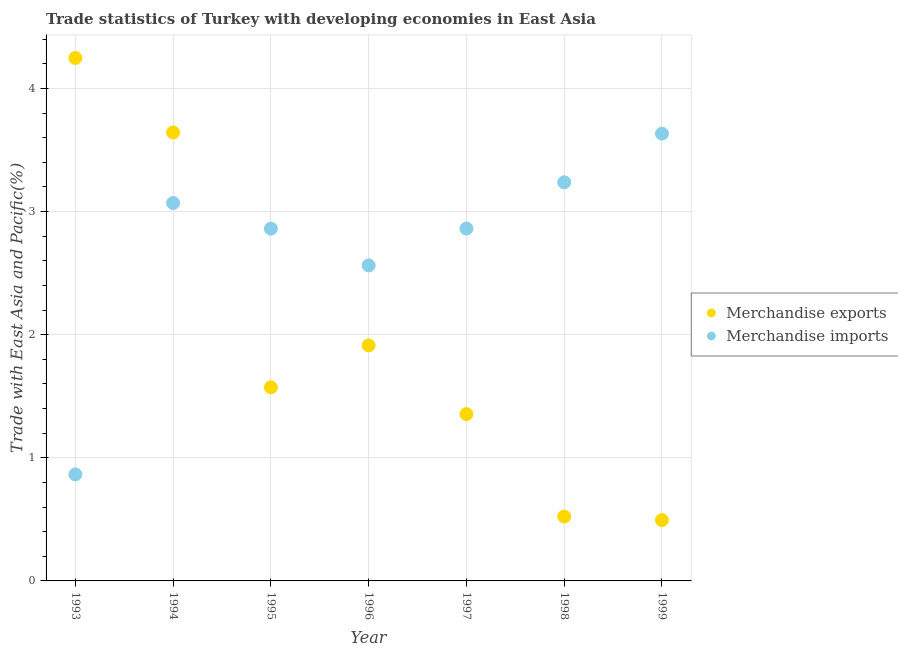How many different coloured dotlines are there?
Give a very brief answer. 2. What is the merchandise exports in 1999?
Your answer should be compact. 0.49. Across all years, what is the maximum merchandise imports?
Make the answer very short. 3.63. Across all years, what is the minimum merchandise exports?
Make the answer very short. 0.49. What is the total merchandise imports in the graph?
Give a very brief answer. 19.09. What is the difference between the merchandise imports in 1998 and that in 1999?
Ensure brevity in your answer.  -0.4. What is the difference between the merchandise exports in 1993 and the merchandise imports in 1996?
Offer a terse response. 1.68. What is the average merchandise exports per year?
Offer a terse response. 1.96. In the year 1996, what is the difference between the merchandise imports and merchandise exports?
Make the answer very short. 0.65. In how many years, is the merchandise exports greater than 0.2 %?
Your answer should be compact. 7. What is the ratio of the merchandise imports in 1993 to that in 1996?
Your response must be concise. 0.34. Is the merchandise imports in 1993 less than that in 1994?
Offer a very short reply. Yes. What is the difference between the highest and the second highest merchandise imports?
Give a very brief answer. 0.4. What is the difference between the highest and the lowest merchandise imports?
Your answer should be very brief. 2.77. Is the merchandise exports strictly greater than the merchandise imports over the years?
Your answer should be compact. No. Is the merchandise exports strictly less than the merchandise imports over the years?
Your answer should be compact. No. How many dotlines are there?
Give a very brief answer. 2. How many years are there in the graph?
Keep it short and to the point. 7. Are the values on the major ticks of Y-axis written in scientific E-notation?
Keep it short and to the point. No. Does the graph contain any zero values?
Your answer should be compact. No. Where does the legend appear in the graph?
Give a very brief answer. Center right. How many legend labels are there?
Offer a terse response. 2. How are the legend labels stacked?
Keep it short and to the point. Vertical. What is the title of the graph?
Keep it short and to the point. Trade statistics of Turkey with developing economies in East Asia. What is the label or title of the Y-axis?
Your answer should be very brief. Trade with East Asia and Pacific(%). What is the Trade with East Asia and Pacific(%) in Merchandise exports in 1993?
Provide a short and direct response. 4.25. What is the Trade with East Asia and Pacific(%) of Merchandise imports in 1993?
Provide a short and direct response. 0.87. What is the Trade with East Asia and Pacific(%) of Merchandise exports in 1994?
Make the answer very short. 3.64. What is the Trade with East Asia and Pacific(%) of Merchandise imports in 1994?
Your answer should be compact. 3.07. What is the Trade with East Asia and Pacific(%) in Merchandise exports in 1995?
Offer a very short reply. 1.57. What is the Trade with East Asia and Pacific(%) in Merchandise imports in 1995?
Provide a short and direct response. 2.86. What is the Trade with East Asia and Pacific(%) of Merchandise exports in 1996?
Provide a short and direct response. 1.91. What is the Trade with East Asia and Pacific(%) of Merchandise imports in 1996?
Provide a short and direct response. 2.56. What is the Trade with East Asia and Pacific(%) in Merchandise exports in 1997?
Offer a very short reply. 1.35. What is the Trade with East Asia and Pacific(%) in Merchandise imports in 1997?
Your response must be concise. 2.86. What is the Trade with East Asia and Pacific(%) of Merchandise exports in 1998?
Your response must be concise. 0.52. What is the Trade with East Asia and Pacific(%) in Merchandise imports in 1998?
Give a very brief answer. 3.24. What is the Trade with East Asia and Pacific(%) in Merchandise exports in 1999?
Your response must be concise. 0.49. What is the Trade with East Asia and Pacific(%) of Merchandise imports in 1999?
Your response must be concise. 3.63. Across all years, what is the maximum Trade with East Asia and Pacific(%) in Merchandise exports?
Your response must be concise. 4.25. Across all years, what is the maximum Trade with East Asia and Pacific(%) of Merchandise imports?
Offer a terse response. 3.63. Across all years, what is the minimum Trade with East Asia and Pacific(%) in Merchandise exports?
Your response must be concise. 0.49. Across all years, what is the minimum Trade with East Asia and Pacific(%) of Merchandise imports?
Your response must be concise. 0.87. What is the total Trade with East Asia and Pacific(%) in Merchandise exports in the graph?
Ensure brevity in your answer.  13.75. What is the total Trade with East Asia and Pacific(%) of Merchandise imports in the graph?
Your response must be concise. 19.09. What is the difference between the Trade with East Asia and Pacific(%) in Merchandise exports in 1993 and that in 1994?
Make the answer very short. 0.6. What is the difference between the Trade with East Asia and Pacific(%) in Merchandise imports in 1993 and that in 1994?
Provide a short and direct response. -2.2. What is the difference between the Trade with East Asia and Pacific(%) in Merchandise exports in 1993 and that in 1995?
Keep it short and to the point. 2.67. What is the difference between the Trade with East Asia and Pacific(%) of Merchandise imports in 1993 and that in 1995?
Provide a succinct answer. -2. What is the difference between the Trade with East Asia and Pacific(%) in Merchandise exports in 1993 and that in 1996?
Your answer should be very brief. 2.33. What is the difference between the Trade with East Asia and Pacific(%) of Merchandise imports in 1993 and that in 1996?
Ensure brevity in your answer.  -1.7. What is the difference between the Trade with East Asia and Pacific(%) of Merchandise exports in 1993 and that in 1997?
Offer a very short reply. 2.89. What is the difference between the Trade with East Asia and Pacific(%) in Merchandise imports in 1993 and that in 1997?
Your response must be concise. -2. What is the difference between the Trade with East Asia and Pacific(%) in Merchandise exports in 1993 and that in 1998?
Your response must be concise. 3.72. What is the difference between the Trade with East Asia and Pacific(%) of Merchandise imports in 1993 and that in 1998?
Offer a very short reply. -2.37. What is the difference between the Trade with East Asia and Pacific(%) of Merchandise exports in 1993 and that in 1999?
Make the answer very short. 3.75. What is the difference between the Trade with East Asia and Pacific(%) of Merchandise imports in 1993 and that in 1999?
Give a very brief answer. -2.77. What is the difference between the Trade with East Asia and Pacific(%) in Merchandise exports in 1994 and that in 1995?
Provide a short and direct response. 2.07. What is the difference between the Trade with East Asia and Pacific(%) in Merchandise imports in 1994 and that in 1995?
Keep it short and to the point. 0.21. What is the difference between the Trade with East Asia and Pacific(%) of Merchandise exports in 1994 and that in 1996?
Make the answer very short. 1.73. What is the difference between the Trade with East Asia and Pacific(%) in Merchandise imports in 1994 and that in 1996?
Offer a very short reply. 0.51. What is the difference between the Trade with East Asia and Pacific(%) in Merchandise exports in 1994 and that in 1997?
Your answer should be compact. 2.29. What is the difference between the Trade with East Asia and Pacific(%) of Merchandise imports in 1994 and that in 1997?
Your response must be concise. 0.21. What is the difference between the Trade with East Asia and Pacific(%) in Merchandise exports in 1994 and that in 1998?
Offer a very short reply. 3.12. What is the difference between the Trade with East Asia and Pacific(%) in Merchandise imports in 1994 and that in 1998?
Offer a terse response. -0.17. What is the difference between the Trade with East Asia and Pacific(%) in Merchandise exports in 1994 and that in 1999?
Give a very brief answer. 3.15. What is the difference between the Trade with East Asia and Pacific(%) of Merchandise imports in 1994 and that in 1999?
Keep it short and to the point. -0.56. What is the difference between the Trade with East Asia and Pacific(%) in Merchandise exports in 1995 and that in 1996?
Make the answer very short. -0.34. What is the difference between the Trade with East Asia and Pacific(%) in Merchandise imports in 1995 and that in 1996?
Offer a terse response. 0.3. What is the difference between the Trade with East Asia and Pacific(%) in Merchandise exports in 1995 and that in 1997?
Your answer should be compact. 0.22. What is the difference between the Trade with East Asia and Pacific(%) of Merchandise imports in 1995 and that in 1997?
Provide a succinct answer. -0. What is the difference between the Trade with East Asia and Pacific(%) in Merchandise exports in 1995 and that in 1998?
Offer a terse response. 1.05. What is the difference between the Trade with East Asia and Pacific(%) of Merchandise imports in 1995 and that in 1998?
Give a very brief answer. -0.38. What is the difference between the Trade with East Asia and Pacific(%) in Merchandise exports in 1995 and that in 1999?
Ensure brevity in your answer.  1.08. What is the difference between the Trade with East Asia and Pacific(%) in Merchandise imports in 1995 and that in 1999?
Offer a terse response. -0.77. What is the difference between the Trade with East Asia and Pacific(%) of Merchandise exports in 1996 and that in 1997?
Give a very brief answer. 0.56. What is the difference between the Trade with East Asia and Pacific(%) of Merchandise imports in 1996 and that in 1997?
Your response must be concise. -0.3. What is the difference between the Trade with East Asia and Pacific(%) of Merchandise exports in 1996 and that in 1998?
Provide a succinct answer. 1.39. What is the difference between the Trade with East Asia and Pacific(%) of Merchandise imports in 1996 and that in 1998?
Provide a succinct answer. -0.67. What is the difference between the Trade with East Asia and Pacific(%) in Merchandise exports in 1996 and that in 1999?
Provide a short and direct response. 1.42. What is the difference between the Trade with East Asia and Pacific(%) of Merchandise imports in 1996 and that in 1999?
Offer a terse response. -1.07. What is the difference between the Trade with East Asia and Pacific(%) in Merchandise exports in 1997 and that in 1998?
Offer a terse response. 0.83. What is the difference between the Trade with East Asia and Pacific(%) in Merchandise imports in 1997 and that in 1998?
Your response must be concise. -0.38. What is the difference between the Trade with East Asia and Pacific(%) in Merchandise exports in 1997 and that in 1999?
Offer a very short reply. 0.86. What is the difference between the Trade with East Asia and Pacific(%) of Merchandise imports in 1997 and that in 1999?
Your response must be concise. -0.77. What is the difference between the Trade with East Asia and Pacific(%) of Merchandise exports in 1998 and that in 1999?
Make the answer very short. 0.03. What is the difference between the Trade with East Asia and Pacific(%) of Merchandise imports in 1998 and that in 1999?
Make the answer very short. -0.4. What is the difference between the Trade with East Asia and Pacific(%) of Merchandise exports in 1993 and the Trade with East Asia and Pacific(%) of Merchandise imports in 1994?
Provide a succinct answer. 1.18. What is the difference between the Trade with East Asia and Pacific(%) of Merchandise exports in 1993 and the Trade with East Asia and Pacific(%) of Merchandise imports in 1995?
Offer a very short reply. 1.39. What is the difference between the Trade with East Asia and Pacific(%) of Merchandise exports in 1993 and the Trade with East Asia and Pacific(%) of Merchandise imports in 1996?
Keep it short and to the point. 1.68. What is the difference between the Trade with East Asia and Pacific(%) of Merchandise exports in 1993 and the Trade with East Asia and Pacific(%) of Merchandise imports in 1997?
Offer a very short reply. 1.39. What is the difference between the Trade with East Asia and Pacific(%) of Merchandise exports in 1993 and the Trade with East Asia and Pacific(%) of Merchandise imports in 1998?
Provide a succinct answer. 1.01. What is the difference between the Trade with East Asia and Pacific(%) of Merchandise exports in 1993 and the Trade with East Asia and Pacific(%) of Merchandise imports in 1999?
Make the answer very short. 0.61. What is the difference between the Trade with East Asia and Pacific(%) in Merchandise exports in 1994 and the Trade with East Asia and Pacific(%) in Merchandise imports in 1995?
Keep it short and to the point. 0.78. What is the difference between the Trade with East Asia and Pacific(%) in Merchandise exports in 1994 and the Trade with East Asia and Pacific(%) in Merchandise imports in 1996?
Your answer should be compact. 1.08. What is the difference between the Trade with East Asia and Pacific(%) of Merchandise exports in 1994 and the Trade with East Asia and Pacific(%) of Merchandise imports in 1997?
Your response must be concise. 0.78. What is the difference between the Trade with East Asia and Pacific(%) in Merchandise exports in 1994 and the Trade with East Asia and Pacific(%) in Merchandise imports in 1998?
Make the answer very short. 0.4. What is the difference between the Trade with East Asia and Pacific(%) of Merchandise exports in 1994 and the Trade with East Asia and Pacific(%) of Merchandise imports in 1999?
Offer a very short reply. 0.01. What is the difference between the Trade with East Asia and Pacific(%) of Merchandise exports in 1995 and the Trade with East Asia and Pacific(%) of Merchandise imports in 1996?
Offer a terse response. -0.99. What is the difference between the Trade with East Asia and Pacific(%) in Merchandise exports in 1995 and the Trade with East Asia and Pacific(%) in Merchandise imports in 1997?
Your response must be concise. -1.29. What is the difference between the Trade with East Asia and Pacific(%) of Merchandise exports in 1995 and the Trade with East Asia and Pacific(%) of Merchandise imports in 1998?
Provide a short and direct response. -1.67. What is the difference between the Trade with East Asia and Pacific(%) in Merchandise exports in 1995 and the Trade with East Asia and Pacific(%) in Merchandise imports in 1999?
Provide a short and direct response. -2.06. What is the difference between the Trade with East Asia and Pacific(%) in Merchandise exports in 1996 and the Trade with East Asia and Pacific(%) in Merchandise imports in 1997?
Offer a terse response. -0.95. What is the difference between the Trade with East Asia and Pacific(%) in Merchandise exports in 1996 and the Trade with East Asia and Pacific(%) in Merchandise imports in 1998?
Make the answer very short. -1.32. What is the difference between the Trade with East Asia and Pacific(%) of Merchandise exports in 1996 and the Trade with East Asia and Pacific(%) of Merchandise imports in 1999?
Offer a terse response. -1.72. What is the difference between the Trade with East Asia and Pacific(%) of Merchandise exports in 1997 and the Trade with East Asia and Pacific(%) of Merchandise imports in 1998?
Your answer should be compact. -1.88. What is the difference between the Trade with East Asia and Pacific(%) of Merchandise exports in 1997 and the Trade with East Asia and Pacific(%) of Merchandise imports in 1999?
Offer a terse response. -2.28. What is the difference between the Trade with East Asia and Pacific(%) in Merchandise exports in 1998 and the Trade with East Asia and Pacific(%) in Merchandise imports in 1999?
Offer a very short reply. -3.11. What is the average Trade with East Asia and Pacific(%) of Merchandise exports per year?
Keep it short and to the point. 1.96. What is the average Trade with East Asia and Pacific(%) of Merchandise imports per year?
Your answer should be very brief. 2.73. In the year 1993, what is the difference between the Trade with East Asia and Pacific(%) in Merchandise exports and Trade with East Asia and Pacific(%) in Merchandise imports?
Give a very brief answer. 3.38. In the year 1994, what is the difference between the Trade with East Asia and Pacific(%) of Merchandise exports and Trade with East Asia and Pacific(%) of Merchandise imports?
Make the answer very short. 0.57. In the year 1995, what is the difference between the Trade with East Asia and Pacific(%) of Merchandise exports and Trade with East Asia and Pacific(%) of Merchandise imports?
Your answer should be very brief. -1.29. In the year 1996, what is the difference between the Trade with East Asia and Pacific(%) of Merchandise exports and Trade with East Asia and Pacific(%) of Merchandise imports?
Provide a succinct answer. -0.65. In the year 1997, what is the difference between the Trade with East Asia and Pacific(%) in Merchandise exports and Trade with East Asia and Pacific(%) in Merchandise imports?
Your response must be concise. -1.51. In the year 1998, what is the difference between the Trade with East Asia and Pacific(%) of Merchandise exports and Trade with East Asia and Pacific(%) of Merchandise imports?
Make the answer very short. -2.71. In the year 1999, what is the difference between the Trade with East Asia and Pacific(%) in Merchandise exports and Trade with East Asia and Pacific(%) in Merchandise imports?
Provide a short and direct response. -3.14. What is the ratio of the Trade with East Asia and Pacific(%) of Merchandise exports in 1993 to that in 1994?
Provide a succinct answer. 1.17. What is the ratio of the Trade with East Asia and Pacific(%) of Merchandise imports in 1993 to that in 1994?
Offer a terse response. 0.28. What is the ratio of the Trade with East Asia and Pacific(%) of Merchandise exports in 1993 to that in 1995?
Keep it short and to the point. 2.7. What is the ratio of the Trade with East Asia and Pacific(%) of Merchandise imports in 1993 to that in 1995?
Offer a terse response. 0.3. What is the ratio of the Trade with East Asia and Pacific(%) of Merchandise exports in 1993 to that in 1996?
Offer a very short reply. 2.22. What is the ratio of the Trade with East Asia and Pacific(%) in Merchandise imports in 1993 to that in 1996?
Provide a succinct answer. 0.34. What is the ratio of the Trade with East Asia and Pacific(%) of Merchandise exports in 1993 to that in 1997?
Offer a terse response. 3.13. What is the ratio of the Trade with East Asia and Pacific(%) in Merchandise imports in 1993 to that in 1997?
Keep it short and to the point. 0.3. What is the ratio of the Trade with East Asia and Pacific(%) of Merchandise exports in 1993 to that in 1998?
Offer a very short reply. 8.13. What is the ratio of the Trade with East Asia and Pacific(%) of Merchandise imports in 1993 to that in 1998?
Provide a short and direct response. 0.27. What is the ratio of the Trade with East Asia and Pacific(%) of Merchandise exports in 1993 to that in 1999?
Ensure brevity in your answer.  8.6. What is the ratio of the Trade with East Asia and Pacific(%) of Merchandise imports in 1993 to that in 1999?
Your response must be concise. 0.24. What is the ratio of the Trade with East Asia and Pacific(%) of Merchandise exports in 1994 to that in 1995?
Offer a very short reply. 2.32. What is the ratio of the Trade with East Asia and Pacific(%) of Merchandise imports in 1994 to that in 1995?
Your answer should be compact. 1.07. What is the ratio of the Trade with East Asia and Pacific(%) of Merchandise exports in 1994 to that in 1996?
Ensure brevity in your answer.  1.9. What is the ratio of the Trade with East Asia and Pacific(%) of Merchandise imports in 1994 to that in 1996?
Your answer should be compact. 1.2. What is the ratio of the Trade with East Asia and Pacific(%) in Merchandise exports in 1994 to that in 1997?
Keep it short and to the point. 2.69. What is the ratio of the Trade with East Asia and Pacific(%) of Merchandise imports in 1994 to that in 1997?
Give a very brief answer. 1.07. What is the ratio of the Trade with East Asia and Pacific(%) in Merchandise exports in 1994 to that in 1998?
Make the answer very short. 6.97. What is the ratio of the Trade with East Asia and Pacific(%) of Merchandise imports in 1994 to that in 1998?
Make the answer very short. 0.95. What is the ratio of the Trade with East Asia and Pacific(%) in Merchandise exports in 1994 to that in 1999?
Your answer should be very brief. 7.38. What is the ratio of the Trade with East Asia and Pacific(%) in Merchandise imports in 1994 to that in 1999?
Offer a terse response. 0.84. What is the ratio of the Trade with East Asia and Pacific(%) in Merchandise exports in 1995 to that in 1996?
Provide a succinct answer. 0.82. What is the ratio of the Trade with East Asia and Pacific(%) in Merchandise imports in 1995 to that in 1996?
Make the answer very short. 1.12. What is the ratio of the Trade with East Asia and Pacific(%) in Merchandise exports in 1995 to that in 1997?
Offer a terse response. 1.16. What is the ratio of the Trade with East Asia and Pacific(%) of Merchandise exports in 1995 to that in 1998?
Give a very brief answer. 3.01. What is the ratio of the Trade with East Asia and Pacific(%) of Merchandise imports in 1995 to that in 1998?
Provide a short and direct response. 0.88. What is the ratio of the Trade with East Asia and Pacific(%) of Merchandise exports in 1995 to that in 1999?
Ensure brevity in your answer.  3.18. What is the ratio of the Trade with East Asia and Pacific(%) in Merchandise imports in 1995 to that in 1999?
Your answer should be very brief. 0.79. What is the ratio of the Trade with East Asia and Pacific(%) of Merchandise exports in 1996 to that in 1997?
Your answer should be compact. 1.41. What is the ratio of the Trade with East Asia and Pacific(%) of Merchandise imports in 1996 to that in 1997?
Make the answer very short. 0.9. What is the ratio of the Trade with East Asia and Pacific(%) of Merchandise exports in 1996 to that in 1998?
Your answer should be very brief. 3.66. What is the ratio of the Trade with East Asia and Pacific(%) in Merchandise imports in 1996 to that in 1998?
Your answer should be compact. 0.79. What is the ratio of the Trade with East Asia and Pacific(%) in Merchandise exports in 1996 to that in 1999?
Offer a very short reply. 3.88. What is the ratio of the Trade with East Asia and Pacific(%) in Merchandise imports in 1996 to that in 1999?
Your answer should be compact. 0.71. What is the ratio of the Trade with East Asia and Pacific(%) of Merchandise exports in 1997 to that in 1998?
Keep it short and to the point. 2.59. What is the ratio of the Trade with East Asia and Pacific(%) in Merchandise imports in 1997 to that in 1998?
Ensure brevity in your answer.  0.88. What is the ratio of the Trade with East Asia and Pacific(%) in Merchandise exports in 1997 to that in 1999?
Keep it short and to the point. 2.74. What is the ratio of the Trade with East Asia and Pacific(%) in Merchandise imports in 1997 to that in 1999?
Offer a very short reply. 0.79. What is the ratio of the Trade with East Asia and Pacific(%) in Merchandise exports in 1998 to that in 1999?
Keep it short and to the point. 1.06. What is the ratio of the Trade with East Asia and Pacific(%) of Merchandise imports in 1998 to that in 1999?
Your answer should be compact. 0.89. What is the difference between the highest and the second highest Trade with East Asia and Pacific(%) of Merchandise exports?
Your response must be concise. 0.6. What is the difference between the highest and the second highest Trade with East Asia and Pacific(%) in Merchandise imports?
Your answer should be very brief. 0.4. What is the difference between the highest and the lowest Trade with East Asia and Pacific(%) in Merchandise exports?
Ensure brevity in your answer.  3.75. What is the difference between the highest and the lowest Trade with East Asia and Pacific(%) in Merchandise imports?
Keep it short and to the point. 2.77. 